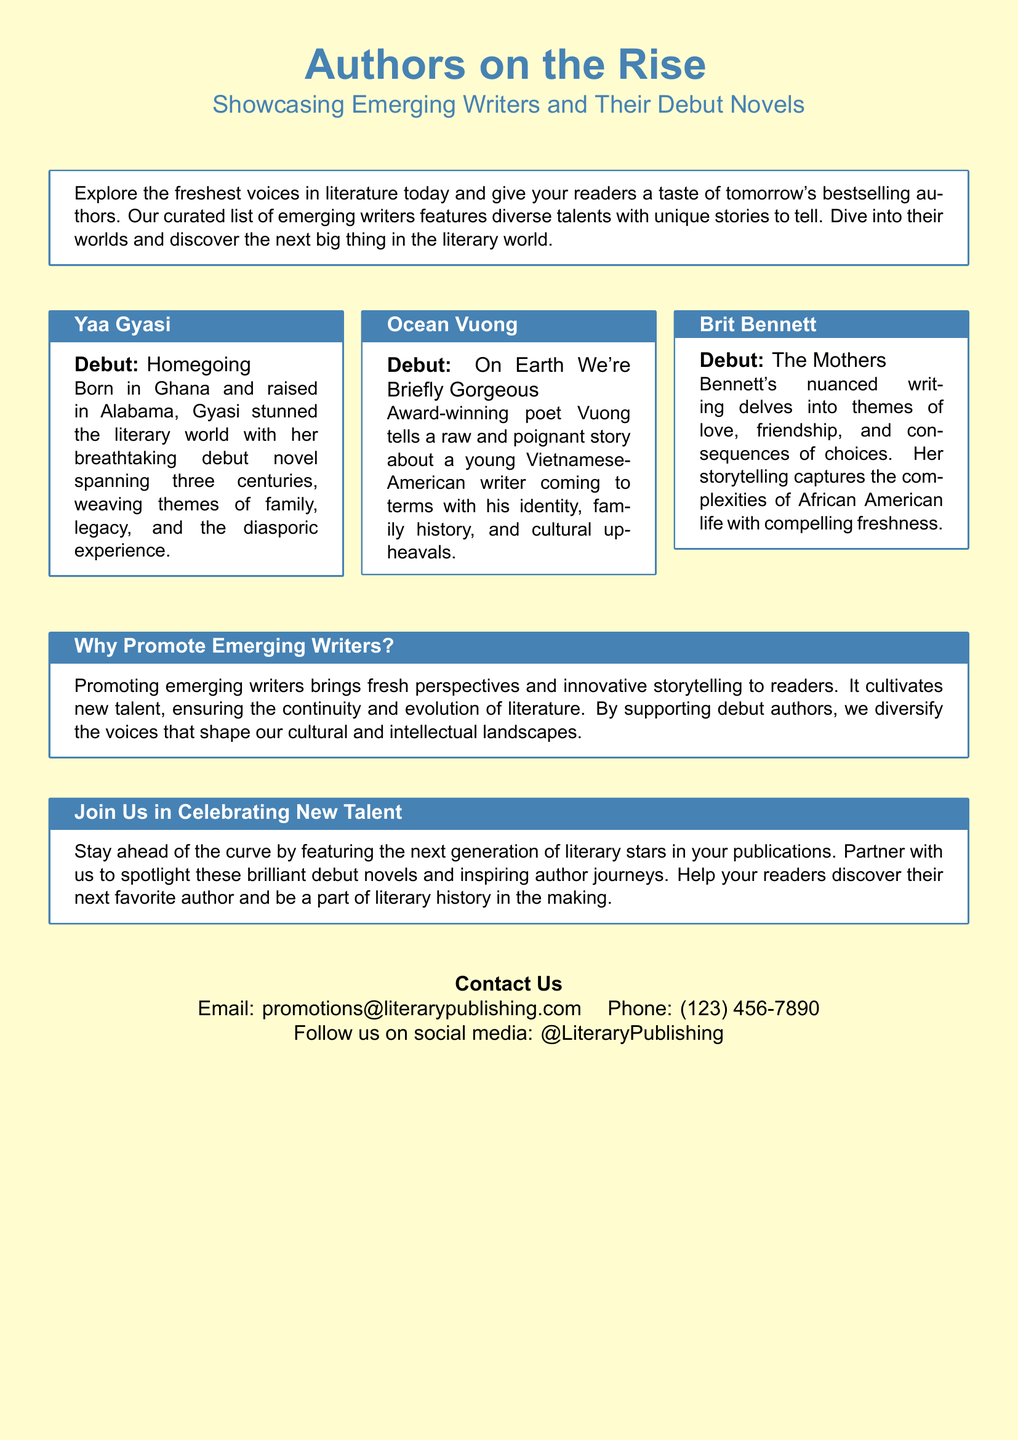what is the title of Yaa Gyasi's debut novel? Yaa Gyasi's debut novel is mentioned in the document as "Homegoing."
Answer: Homegoing who is the author of "On Earth We're Briefly Gorgeous"? The author of this debut novel is named in the document as Ocean Vuong.
Answer: Ocean Vuong how many authors are showcased in this document? The document showcases three emerging authors.
Answer: three what are some themes explored in Yaa Gyasi's "Homegoing"? The document mentions that Gyasi's novel weaves themes of family, legacy, and the diasporic experience.
Answer: family, legacy, diasporic experience what is the focus of the advertisement? The advertisement highlights emerging writers and their debut novels while encouraging support for new talent in literature.
Answer: emerging writers and their debut novels what is the contact email provided in the document? The document provides a contact email for promotions as "promotions@literarypublishing.com."
Answer: promotions@literarypublishing.com what does promoting emerging writers ensure? The document states that promoting emerging writers ensures the continuity and evolution of literature.
Answer: continuity and evolution of literature what genre of writing is Ocean Vuong known for? The document states that Ocean Vuong is an award-winning poet.
Answer: poet what is one reason given for promoting debut authors? The document mentions diversifying the voices that shape our cultural and intellectual landscapes as a reason.
Answer: diversify voices 